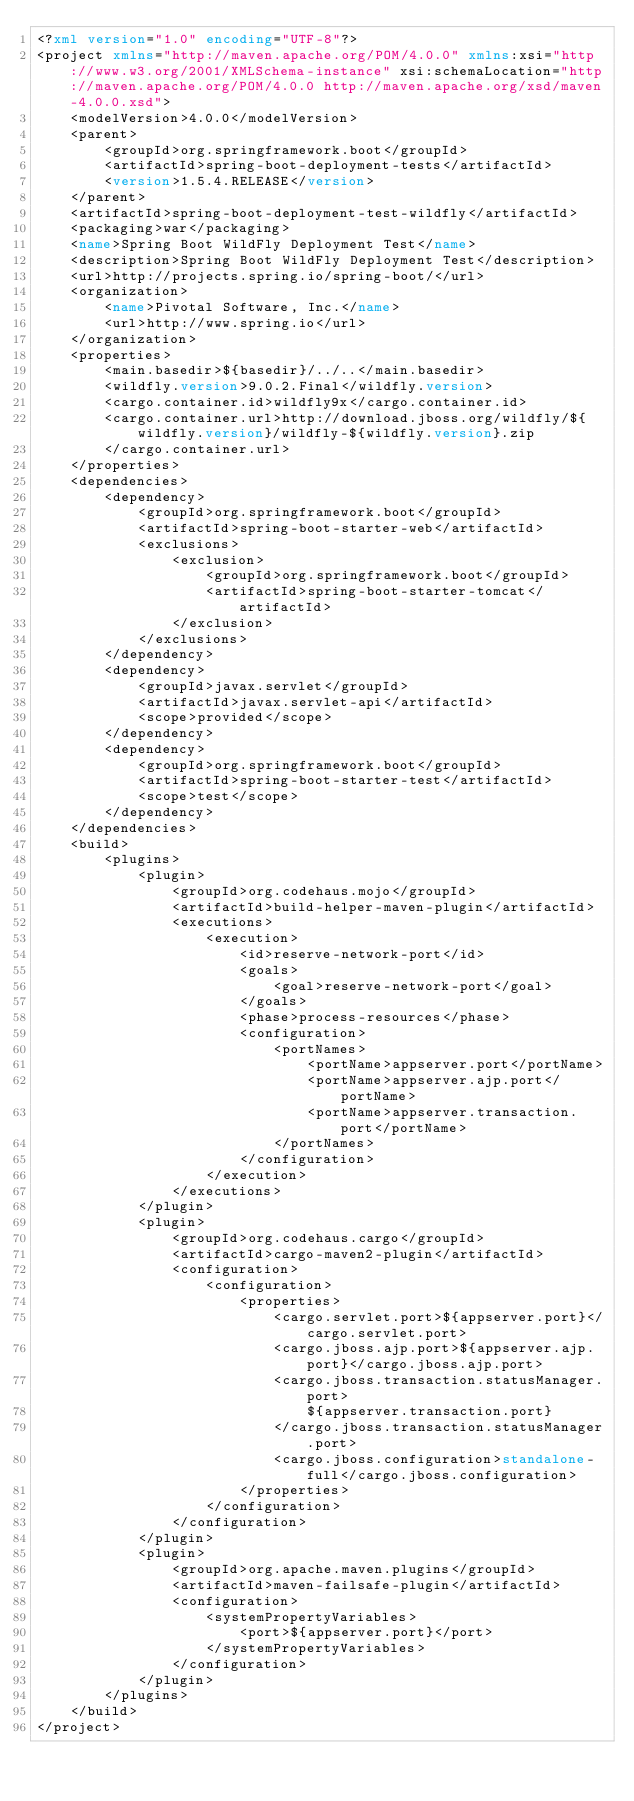<code> <loc_0><loc_0><loc_500><loc_500><_XML_><?xml version="1.0" encoding="UTF-8"?>
<project xmlns="http://maven.apache.org/POM/4.0.0" xmlns:xsi="http://www.w3.org/2001/XMLSchema-instance" xsi:schemaLocation="http://maven.apache.org/POM/4.0.0 http://maven.apache.org/xsd/maven-4.0.0.xsd">
	<modelVersion>4.0.0</modelVersion>
	<parent>
		<groupId>org.springframework.boot</groupId>
		<artifactId>spring-boot-deployment-tests</artifactId>
		<version>1.5.4.RELEASE</version>
	</parent>
	<artifactId>spring-boot-deployment-test-wildfly</artifactId>
	<packaging>war</packaging>
	<name>Spring Boot WildFly Deployment Test</name>
	<description>Spring Boot WildFly Deployment Test</description>
	<url>http://projects.spring.io/spring-boot/</url>
	<organization>
		<name>Pivotal Software, Inc.</name>
		<url>http://www.spring.io</url>
	</organization>
	<properties>
		<main.basedir>${basedir}/../..</main.basedir>
		<wildfly.version>9.0.2.Final</wildfly.version>
		<cargo.container.id>wildfly9x</cargo.container.id>
		<cargo.container.url>http://download.jboss.org/wildfly/${wildfly.version}/wildfly-${wildfly.version}.zip
		</cargo.container.url>
	</properties>
	<dependencies>
		<dependency>
			<groupId>org.springframework.boot</groupId>
			<artifactId>spring-boot-starter-web</artifactId>
			<exclusions>
				<exclusion>
					<groupId>org.springframework.boot</groupId>
					<artifactId>spring-boot-starter-tomcat</artifactId>
				</exclusion>
			</exclusions>
		</dependency>
		<dependency>
			<groupId>javax.servlet</groupId>
			<artifactId>javax.servlet-api</artifactId>
			<scope>provided</scope>
		</dependency>
		<dependency>
			<groupId>org.springframework.boot</groupId>
			<artifactId>spring-boot-starter-test</artifactId>
			<scope>test</scope>
		</dependency>
	</dependencies>
	<build>
		<plugins>
			<plugin>
				<groupId>org.codehaus.mojo</groupId>
				<artifactId>build-helper-maven-plugin</artifactId>
				<executions>
					<execution>
						<id>reserve-network-port</id>
						<goals>
							<goal>reserve-network-port</goal>
						</goals>
						<phase>process-resources</phase>
						<configuration>
							<portNames>
								<portName>appserver.port</portName>
								<portName>appserver.ajp.port</portName>
								<portName>appserver.transaction.port</portName>
							</portNames>
						</configuration>
					</execution>
				</executions>
			</plugin>
			<plugin>
				<groupId>org.codehaus.cargo</groupId>
				<artifactId>cargo-maven2-plugin</artifactId>
				<configuration>
					<configuration>
						<properties>
							<cargo.servlet.port>${appserver.port}</cargo.servlet.port>
							<cargo.jboss.ajp.port>${appserver.ajp.port}</cargo.jboss.ajp.port>
							<cargo.jboss.transaction.statusManager.port>
								${appserver.transaction.port}
							</cargo.jboss.transaction.statusManager.port>
							<cargo.jboss.configuration>standalone-full</cargo.jboss.configuration>
						</properties>
					</configuration>
				</configuration>
			</plugin>
			<plugin>
				<groupId>org.apache.maven.plugins</groupId>
				<artifactId>maven-failsafe-plugin</artifactId>
				<configuration>
					<systemPropertyVariables>
						<port>${appserver.port}</port>
					</systemPropertyVariables>
				</configuration>
			</plugin>
		</plugins>
	</build>
</project>
</code> 